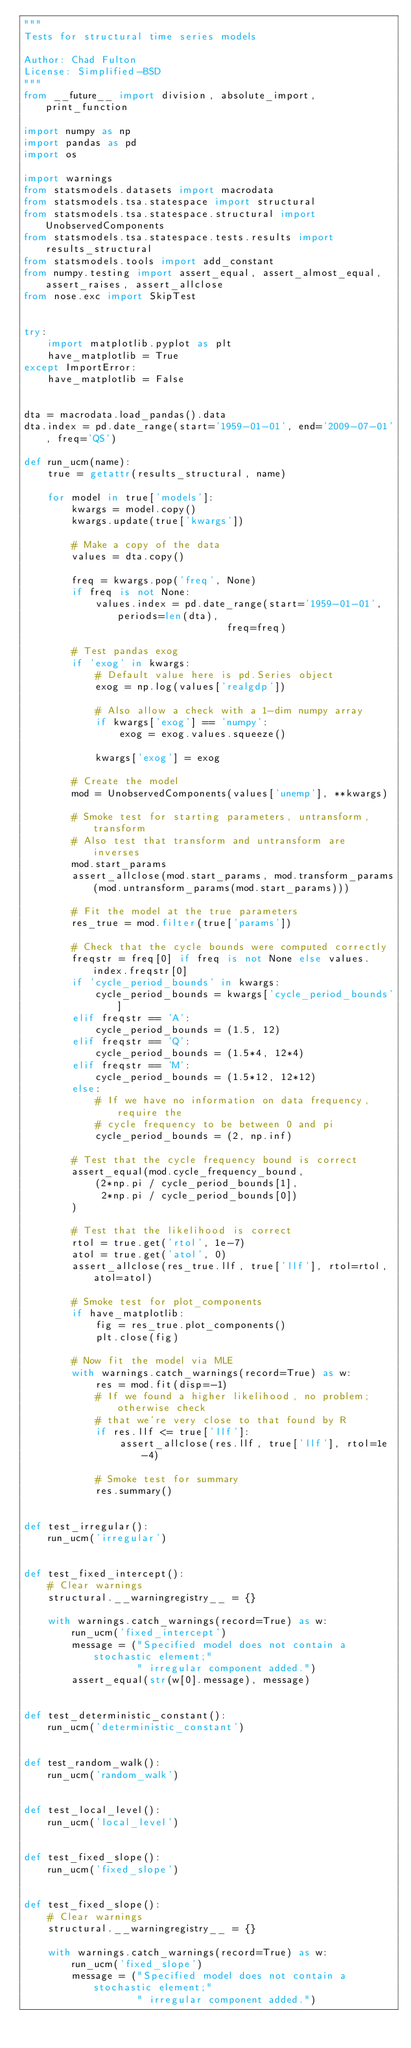Convert code to text. <code><loc_0><loc_0><loc_500><loc_500><_Python_>"""
Tests for structural time series models

Author: Chad Fulton
License: Simplified-BSD
"""
from __future__ import division, absolute_import, print_function

import numpy as np
import pandas as pd
import os

import warnings
from statsmodels.datasets import macrodata
from statsmodels.tsa.statespace import structural
from statsmodels.tsa.statespace.structural import UnobservedComponents
from statsmodels.tsa.statespace.tests.results import results_structural
from statsmodels.tools import add_constant
from numpy.testing import assert_equal, assert_almost_equal, assert_raises, assert_allclose
from nose.exc import SkipTest


try:
    import matplotlib.pyplot as plt
    have_matplotlib = True
except ImportError:
    have_matplotlib = False


dta = macrodata.load_pandas().data
dta.index = pd.date_range(start='1959-01-01', end='2009-07-01', freq='QS')

def run_ucm(name):
    true = getattr(results_structural, name)

    for model in true['models']:
        kwargs = model.copy()
        kwargs.update(true['kwargs'])

        # Make a copy of the data
        values = dta.copy()

        freq = kwargs.pop('freq', None)
        if freq is not None:
            values.index = pd.date_range(start='1959-01-01', periods=len(dta),
                                  freq=freq)

        # Test pandas exog
        if 'exog' in kwargs:
            # Default value here is pd.Series object
            exog = np.log(values['realgdp'])

            # Also allow a check with a 1-dim numpy array
            if kwargs['exog'] == 'numpy':
                exog = exog.values.squeeze()
            
            kwargs['exog'] = exog

        # Create the model
        mod = UnobservedComponents(values['unemp'], **kwargs)

        # Smoke test for starting parameters, untransform, transform
        # Also test that transform and untransform are inverses
        mod.start_params
        assert_allclose(mod.start_params, mod.transform_params(mod.untransform_params(mod.start_params)))

        # Fit the model at the true parameters
        res_true = mod.filter(true['params'])

        # Check that the cycle bounds were computed correctly
        freqstr = freq[0] if freq is not None else values.index.freqstr[0]
        if 'cycle_period_bounds' in kwargs:
            cycle_period_bounds = kwargs['cycle_period_bounds']
        elif freqstr == 'A':
            cycle_period_bounds = (1.5, 12)
        elif freqstr == 'Q':
            cycle_period_bounds = (1.5*4, 12*4)
        elif freqstr == 'M':
            cycle_period_bounds = (1.5*12, 12*12)
        else:
            # If we have no information on data frequency, require the
            # cycle frequency to be between 0 and pi
            cycle_period_bounds = (2, np.inf)

        # Test that the cycle frequency bound is correct
        assert_equal(mod.cycle_frequency_bound,
            (2*np.pi / cycle_period_bounds[1],
             2*np.pi / cycle_period_bounds[0])
        )

        # Test that the likelihood is correct
        rtol = true.get('rtol', 1e-7)
        atol = true.get('atol', 0)
        assert_allclose(res_true.llf, true['llf'], rtol=rtol, atol=atol)

        # Smoke test for plot_components
        if have_matplotlib:
            fig = res_true.plot_components()
            plt.close(fig)

        # Now fit the model via MLE
        with warnings.catch_warnings(record=True) as w:
            res = mod.fit(disp=-1)
            # If we found a higher likelihood, no problem; otherwise check
            # that we're very close to that found by R
            if res.llf <= true['llf']:
                assert_allclose(res.llf, true['llf'], rtol=1e-4)

            # Smoke test for summary
            res.summary()


def test_irregular():
    run_ucm('irregular')


def test_fixed_intercept():
    # Clear warnings
    structural.__warningregistry__ = {}

    with warnings.catch_warnings(record=True) as w:
        run_ucm('fixed_intercept')
        message = ("Specified model does not contain a stochastic element;"
                   " irregular component added.")
        assert_equal(str(w[0].message), message)


def test_deterministic_constant():
    run_ucm('deterministic_constant')


def test_random_walk():
    run_ucm('random_walk')


def test_local_level():
    run_ucm('local_level')


def test_fixed_slope():
    run_ucm('fixed_slope')


def test_fixed_slope():
    # Clear warnings
    structural.__warningregistry__ = {}

    with warnings.catch_warnings(record=True) as w:
        run_ucm('fixed_slope')
        message = ("Specified model does not contain a stochastic element;"
                   " irregular component added.")</code> 